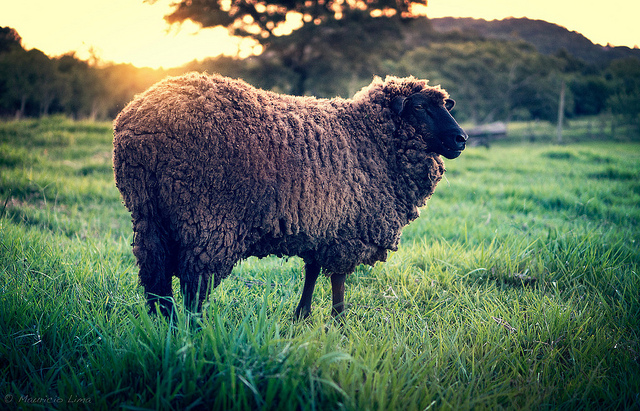Considering the lighting and the background, what time of the day do you think this image was taken? Judging by the warm, golden light illuminating the scene and the long shadows cast by the objects, I would infer that this image was likely taken either during sunrise or sunset. This lighting adds a tranquil and serene ambiance to the picture. 